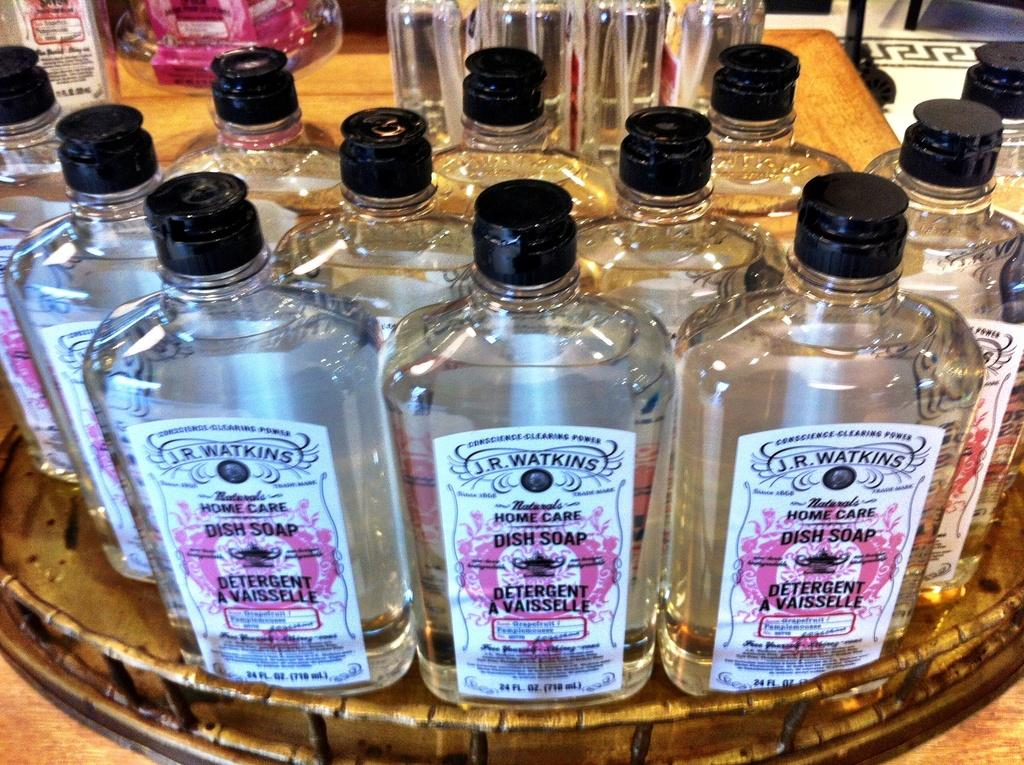<image>
Present a compact description of the photo's key features. Glass bottles of J. R. Watkins dish soap on a tray. 